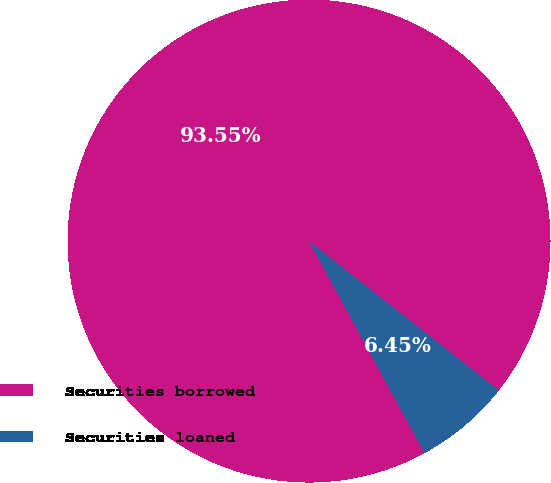Convert chart to OTSL. <chart><loc_0><loc_0><loc_500><loc_500><pie_chart><fcel>Securities borrowed<fcel>Securities loaned<nl><fcel>93.55%<fcel>6.45%<nl></chart> 